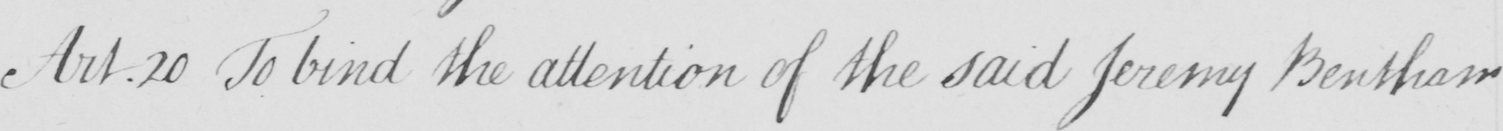Please provide the text content of this handwritten line. Art.20 To bind the attention of the said Jeremy Bentham 